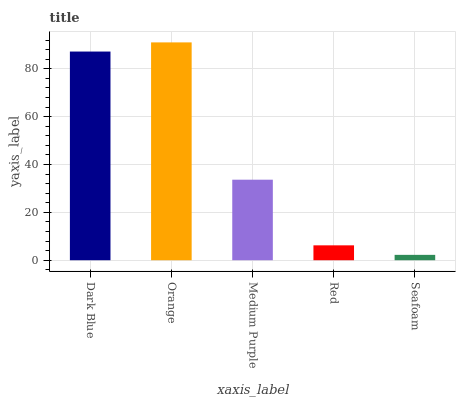Is Seafoam the minimum?
Answer yes or no. Yes. Is Orange the maximum?
Answer yes or no. Yes. Is Medium Purple the minimum?
Answer yes or no. No. Is Medium Purple the maximum?
Answer yes or no. No. Is Orange greater than Medium Purple?
Answer yes or no. Yes. Is Medium Purple less than Orange?
Answer yes or no. Yes. Is Medium Purple greater than Orange?
Answer yes or no. No. Is Orange less than Medium Purple?
Answer yes or no. No. Is Medium Purple the high median?
Answer yes or no. Yes. Is Medium Purple the low median?
Answer yes or no. Yes. Is Orange the high median?
Answer yes or no. No. Is Seafoam the low median?
Answer yes or no. No. 